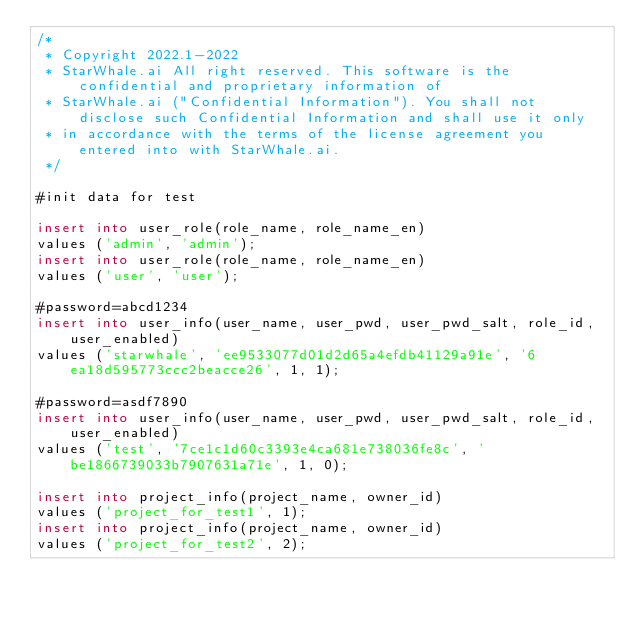Convert code to text. <code><loc_0><loc_0><loc_500><loc_500><_SQL_>/*
 * Copyright 2022.1-2022
 * StarWhale.ai All right reserved. This software is the confidential and proprietary information of
 * StarWhale.ai ("Confidential Information"). You shall not disclose such Confidential Information and shall use it only
 * in accordance with the terms of the license agreement you entered into with StarWhale.ai.
 */

#init data for test

insert into user_role(role_name, role_name_en)
values ('admin', 'admin');
insert into user_role(role_name, role_name_en)
values ('user', 'user');

#password=abcd1234
insert into user_info(user_name, user_pwd, user_pwd_salt, role_id, user_enabled)
values ('starwhale', 'ee9533077d01d2d65a4efdb41129a91e', '6ea18d595773ccc2beacce26', 1, 1);

#password=asdf7890
insert into user_info(user_name, user_pwd, user_pwd_salt, role_id, user_enabled)
values ('test', '7ce1c1d60c3393e4ca681e738036fe8c', 'be1866739033b7907631a71e', 1, 0);

insert into project_info(project_name, owner_id)
values ('project_for_test1', 1);
insert into project_info(project_name, owner_id)
values ('project_for_test2', 2);

</code> 